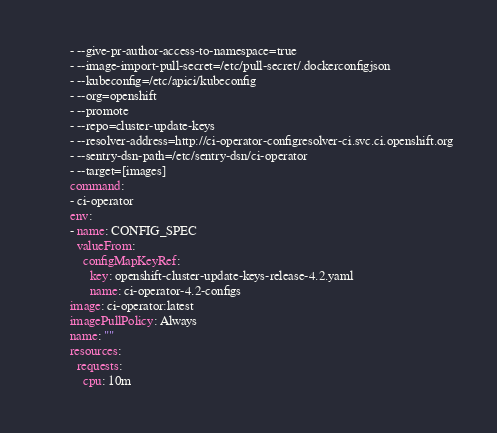<code> <loc_0><loc_0><loc_500><loc_500><_YAML_>        - --give-pr-author-access-to-namespace=true
        - --image-import-pull-secret=/etc/pull-secret/.dockerconfigjson
        - --kubeconfig=/etc/apici/kubeconfig
        - --org=openshift
        - --promote
        - --repo=cluster-update-keys
        - --resolver-address=http://ci-operator-configresolver-ci.svc.ci.openshift.org
        - --sentry-dsn-path=/etc/sentry-dsn/ci-operator
        - --target=[images]
        command:
        - ci-operator
        env:
        - name: CONFIG_SPEC
          valueFrom:
            configMapKeyRef:
              key: openshift-cluster-update-keys-release-4.2.yaml
              name: ci-operator-4.2-configs
        image: ci-operator:latest
        imagePullPolicy: Always
        name: ""
        resources:
          requests:
            cpu: 10m</code> 